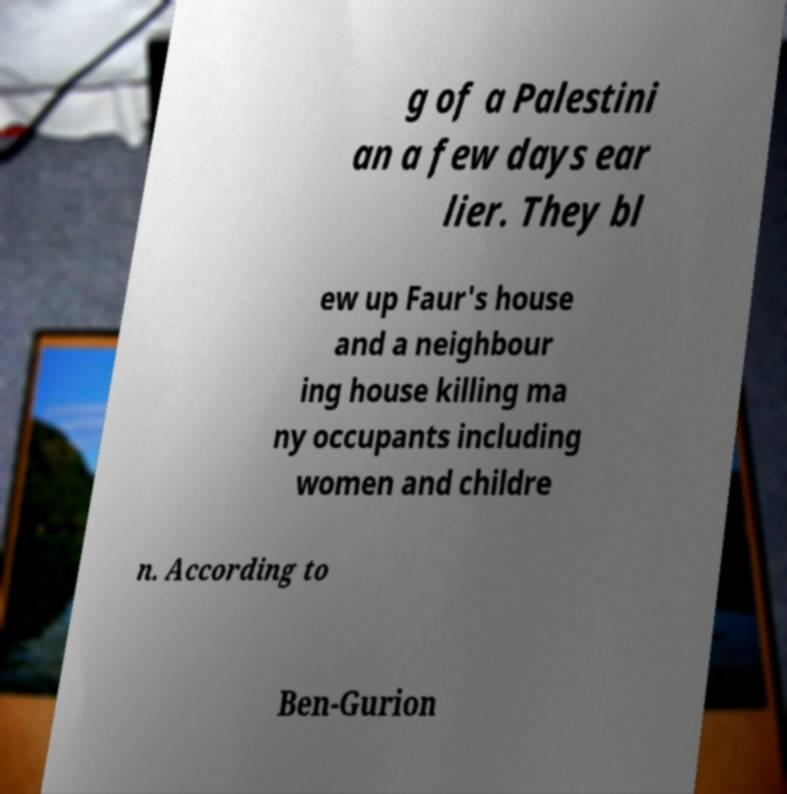Can you accurately transcribe the text from the provided image for me? g of a Palestini an a few days ear lier. They bl ew up Faur's house and a neighbour ing house killing ma ny occupants including women and childre n. According to Ben-Gurion 